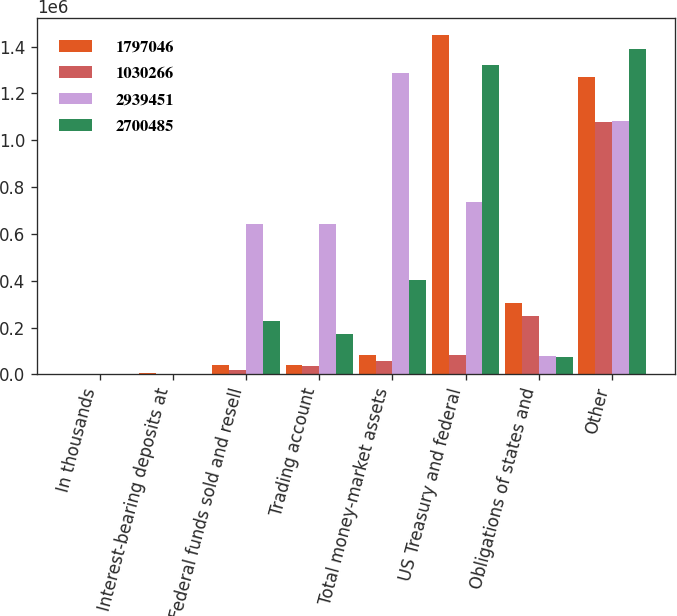Convert chart. <chart><loc_0><loc_0><loc_500><loc_500><stacked_bar_chart><ecel><fcel>In thousands<fcel>Interest-bearing deposits at<fcel>Federal funds sold and resell<fcel>Trading account<fcel>Total money-market assets<fcel>US Treasury and federal<fcel>Obligations of states and<fcel>Other<nl><fcel>1.79705e+06<fcel>2001<fcel>4341<fcel>41086<fcel>38929<fcel>84356<fcel>1.4484e+06<fcel>306768<fcel>1.26897e+06<nl><fcel>1.03027e+06<fcel>2000<fcel>3102<fcel>17261<fcel>37431<fcel>57794<fcel>84356<fcel>249425<fcel>1.07608e+06<nl><fcel>2.93945e+06<fcel>1999<fcel>1092<fcel>643555<fcel>641114<fcel>1.28576e+06<fcel>737586<fcel>79189<fcel>1.08375e+06<nl><fcel>2.70048e+06<fcel>1998<fcel>674<fcel>229066<fcel>173122<fcel>402862<fcel>1.321e+06<fcel>73789<fcel>1.39078e+06<nl></chart> 